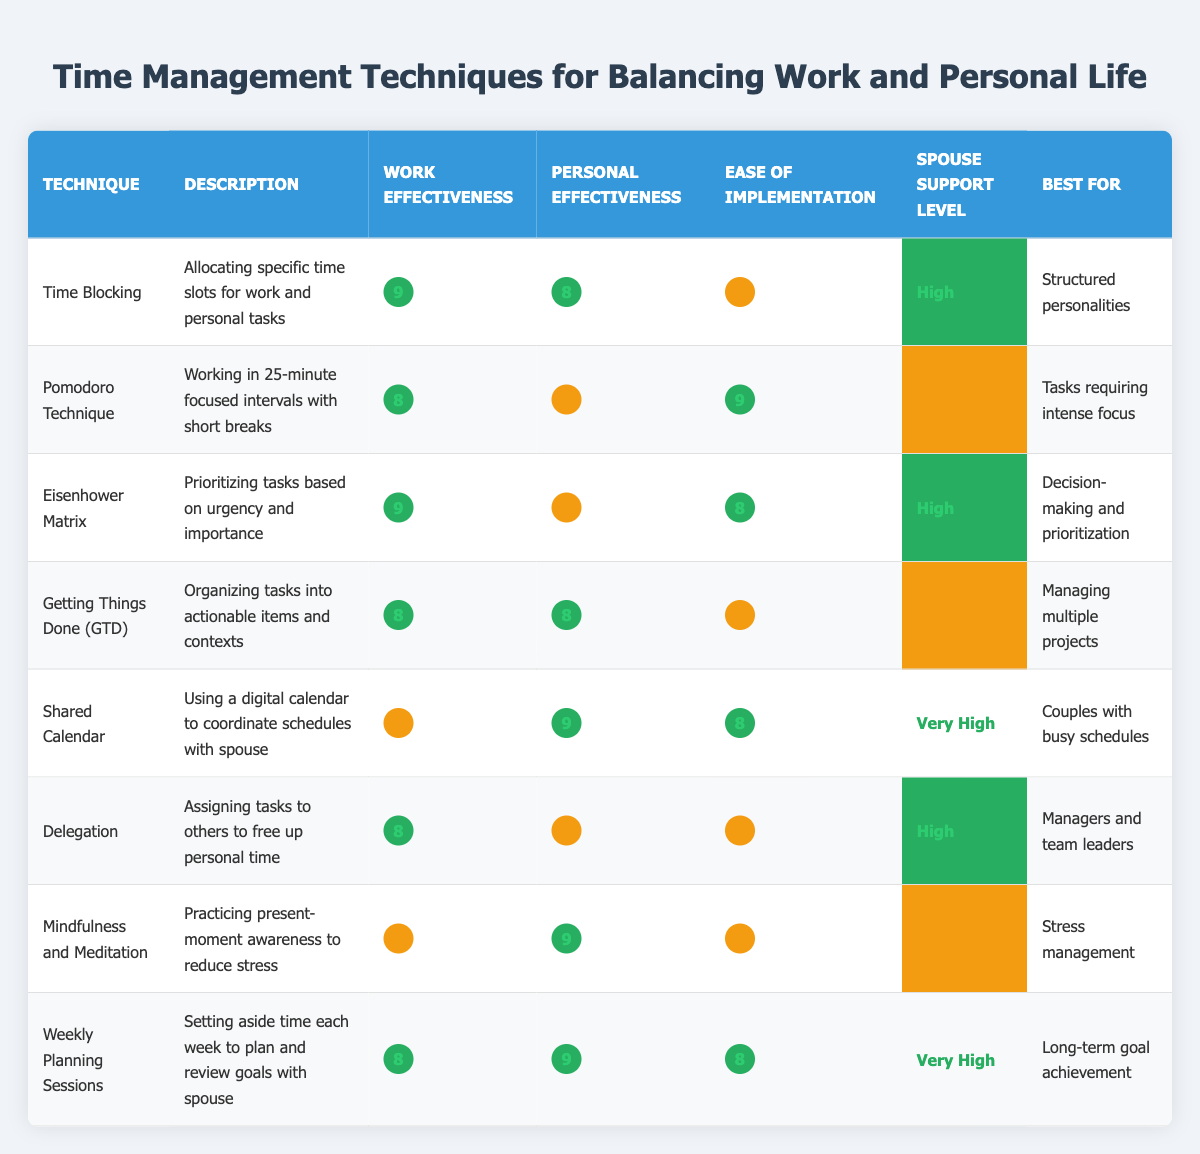What is the effectiveness for work of the Mindfulness and Meditation technique? The table shows that the effectiveness for work of the Mindfulness and Meditation technique is listed as 7.
Answer: 7 Which time management technique has the highest effectiveness for personal life? By examining the "Personal Effectiveness" column, the highest value is 9, which corresponds to both the Shared Calendar and Mindfulness and Meditation techniques.
Answer: Shared Calendar and Mindfulness and Meditation What is the ease of implementation for Getting Things Done (GTD)? The table indicates that the ease of implementation for the Getting Things Done (GTD) technique is rated as 6.
Answer: 6 Is the Spouse Support Level for Weekly Planning Sessions classified as High? The table shows that the Spouse Support Level for Weekly Planning Sessions is categorized as Very High, not just High. Therefore, the answer is no.
Answer: No Calculate the average effectiveness for work across all techniques. Adding the effectiveness values for work: 9 + 8 + 9 + 8 + 7 + 8 + 7 + 8 = 66, and dividing by 8 techniques gives 66 / 8 = 8.25.
Answer: 8.25 How does the effectiveness for personal life of the Eisenhower Matrix compare to that of Shared Calendar? The Eisenhower Matrix has an effectiveness for personal life of 7, while the Shared Calendar has an effectiveness of 9. Since 9 is greater than 7, Shared Calendar is more effective for personal life.
Answer: Shared Calendar is more effective What is the best technique for couples with busy schedules? The table lists the Shared Calendar as the best for couples with busy schedules, as indicated in the "Best for" column.
Answer: Shared Calendar Which technique has the lowest effectiveness for personal life? The table shows that the Pomodoro Technique has the lowest effectiveness for personal life, rated at 6.
Answer: Pomodoro Technique What is the difference in effectiveness for work between Time Blocking and Getting Things Done (GTD)? The effectiveness for work for Time Blocking is 9, while for Getting Things Done (GTD) it is 8. To find the difference, subtract 8 from 9, which equals 1.
Answer: 1 